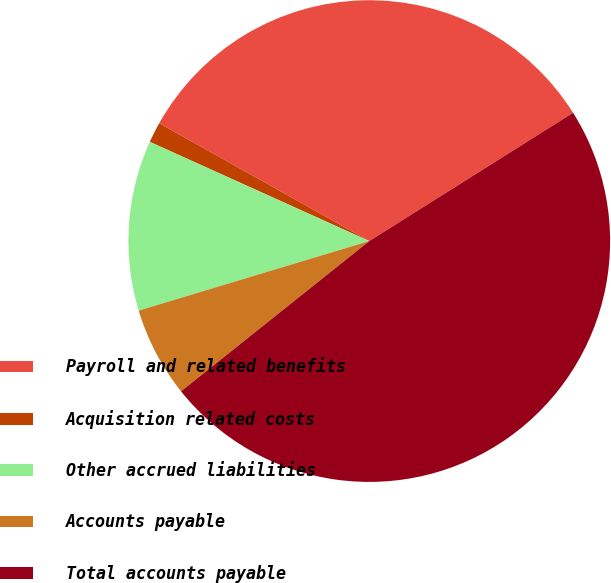Convert chart to OTSL. <chart><loc_0><loc_0><loc_500><loc_500><pie_chart><fcel>Payroll and related benefits<fcel>Acquisition related costs<fcel>Other accrued liabilities<fcel>Accounts payable<fcel>Total accounts payable<nl><fcel>32.92%<fcel>1.38%<fcel>11.42%<fcel>6.06%<fcel>48.22%<nl></chart> 